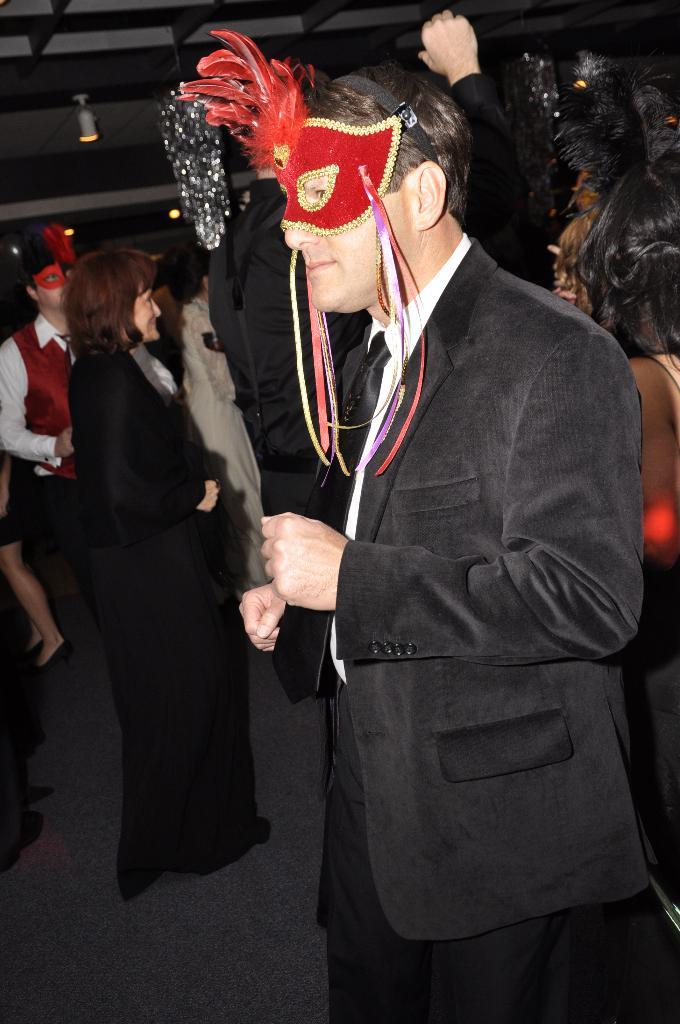What is the main subject in the foreground of the image? There is a man in the foreground of the image. What is the man wearing? The man is wearing a suit. What is on the man's head? The man has a mask on his head. What can be seen in the background of the image? There are people in the background of the image. What are the people doing in the image? The people are standing on the floor. What is present on the ceiling in the image? There are lights on the ceiling. Where is the grandmother sitting in the image? There is no grandmother present in the image. What type of insect can be seen crawling on the man's suit? There are no insects visible on the man's suit in the image. 